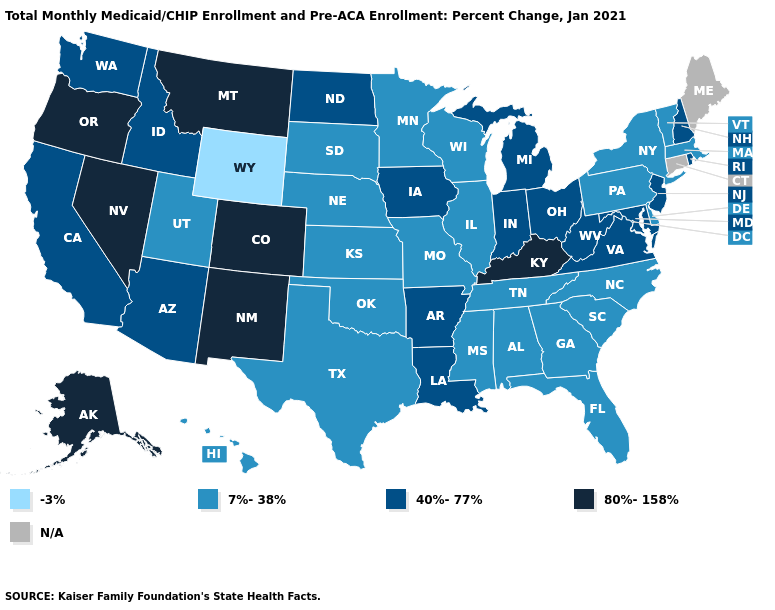Is the legend a continuous bar?
Answer briefly. No. What is the value of Florida?
Give a very brief answer. 7%-38%. What is the value of Wyoming?
Keep it brief. -3%. Name the states that have a value in the range 80%-158%?
Be succinct. Alaska, Colorado, Kentucky, Montana, Nevada, New Mexico, Oregon. What is the value of New Mexico?
Short answer required. 80%-158%. Among the states that border New York , which have the lowest value?
Keep it brief. Massachusetts, Pennsylvania, Vermont. What is the lowest value in states that border Maryland?
Answer briefly. 7%-38%. Name the states that have a value in the range 40%-77%?
Concise answer only. Arizona, Arkansas, California, Idaho, Indiana, Iowa, Louisiana, Maryland, Michigan, New Hampshire, New Jersey, North Dakota, Ohio, Rhode Island, Virginia, Washington, West Virginia. What is the value of Wisconsin?
Concise answer only. 7%-38%. Name the states that have a value in the range 40%-77%?
Write a very short answer. Arizona, Arkansas, California, Idaho, Indiana, Iowa, Louisiana, Maryland, Michigan, New Hampshire, New Jersey, North Dakota, Ohio, Rhode Island, Virginia, Washington, West Virginia. Is the legend a continuous bar?
Keep it brief. No. What is the value of Alabama?
Concise answer only. 7%-38%. 